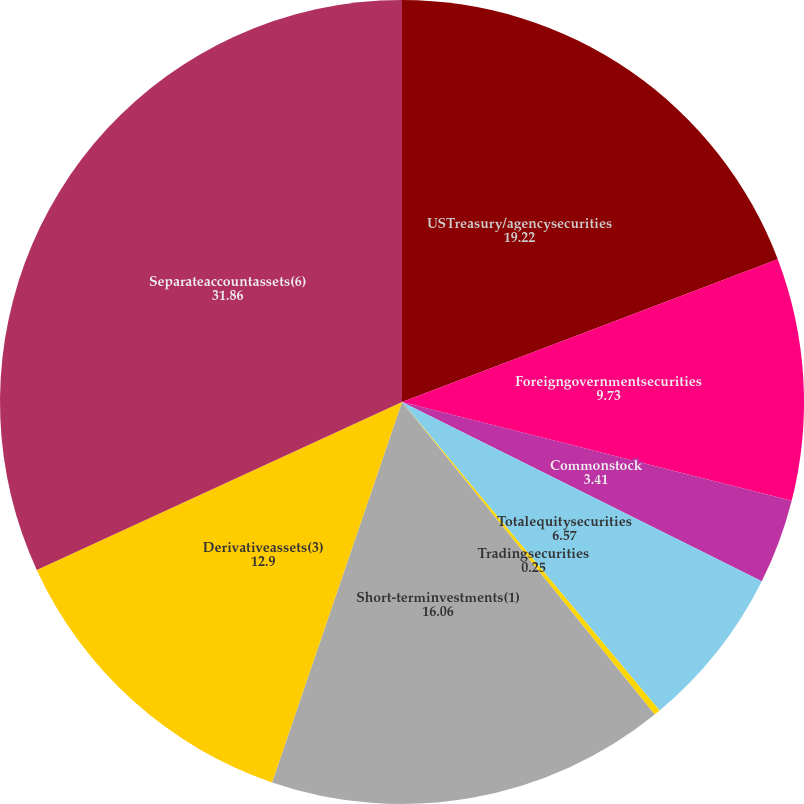Convert chart to OTSL. <chart><loc_0><loc_0><loc_500><loc_500><pie_chart><fcel>USTreasury/agencysecurities<fcel>Foreigngovernmentsecurities<fcel>Commonstock<fcel>Totalequitysecurities<fcel>Tradingsecurities<fcel>Short-terminvestments(1)<fcel>Derivativeassets(3)<fcel>Separateaccountassets(6)<nl><fcel>19.22%<fcel>9.73%<fcel>3.41%<fcel>6.57%<fcel>0.25%<fcel>16.06%<fcel>12.9%<fcel>31.86%<nl></chart> 